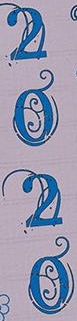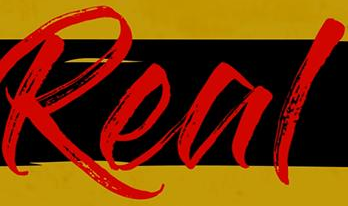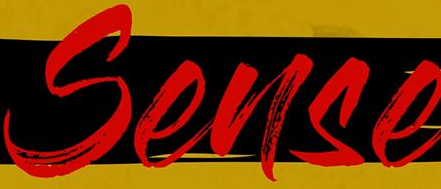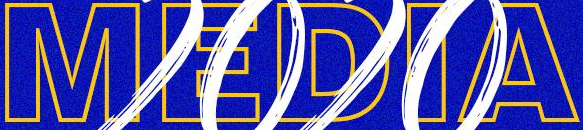Read the text content from these images in order, separated by a semicolon. 2020; Real; Sense; MEDIA 